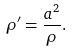<formula> <loc_0><loc_0><loc_500><loc_500>\rho ^ { \prime } = { \frac { a ^ { 2 } } { \rho } } .</formula> 